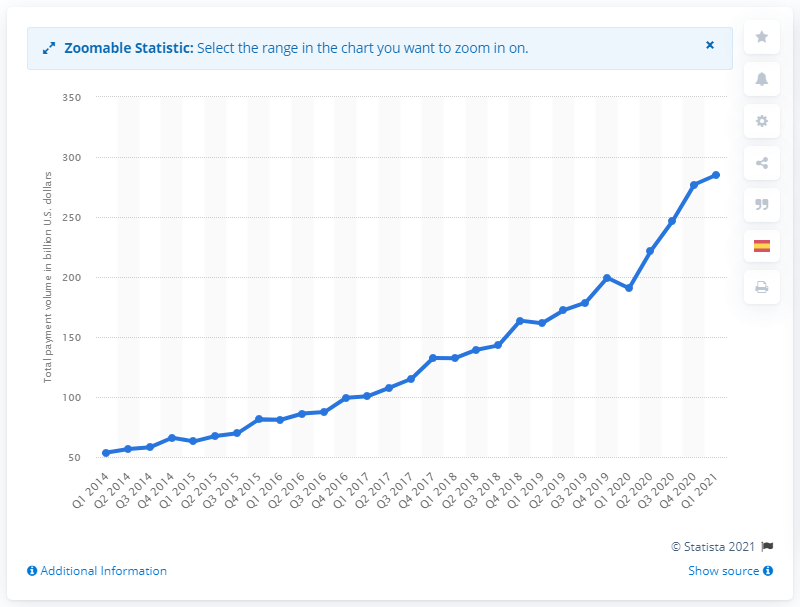Specify some key components in this picture. PayPal's net payment volume in the first quarter of 2021 was approximately 285. 